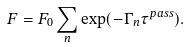Convert formula to latex. <formula><loc_0><loc_0><loc_500><loc_500>F = F _ { 0 } \sum _ { n } \exp ( - \Gamma _ { n } \tau ^ { p a s s } ) .</formula> 